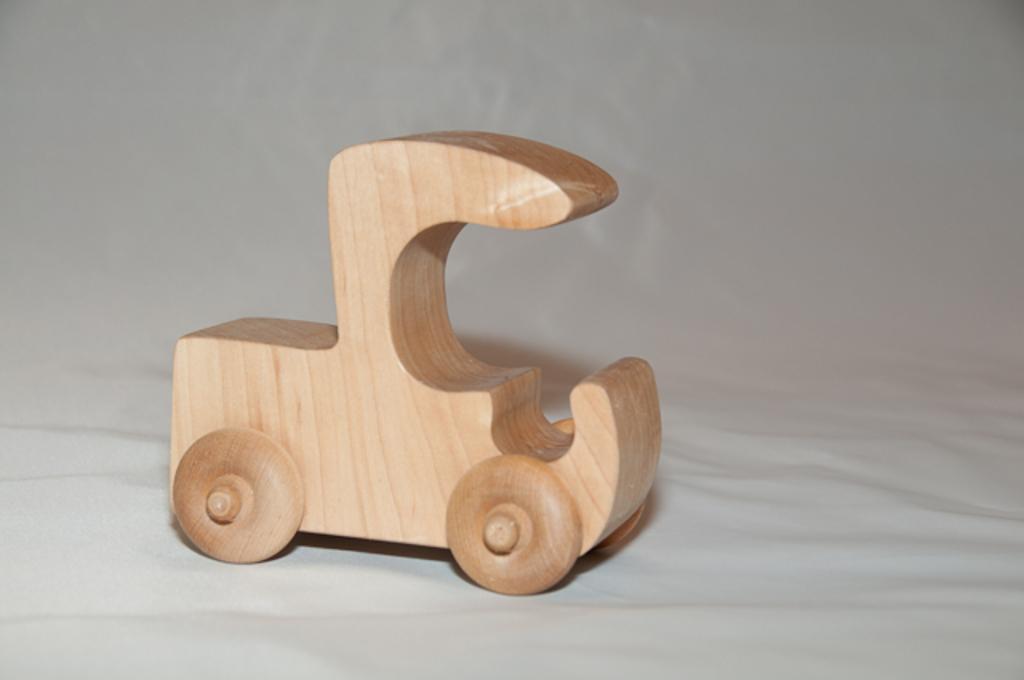How would you summarize this image in a sentence or two? Here we can see a wooden toy on white surface. 